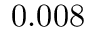<formula> <loc_0><loc_0><loc_500><loc_500>0 . 0 0 8</formula> 